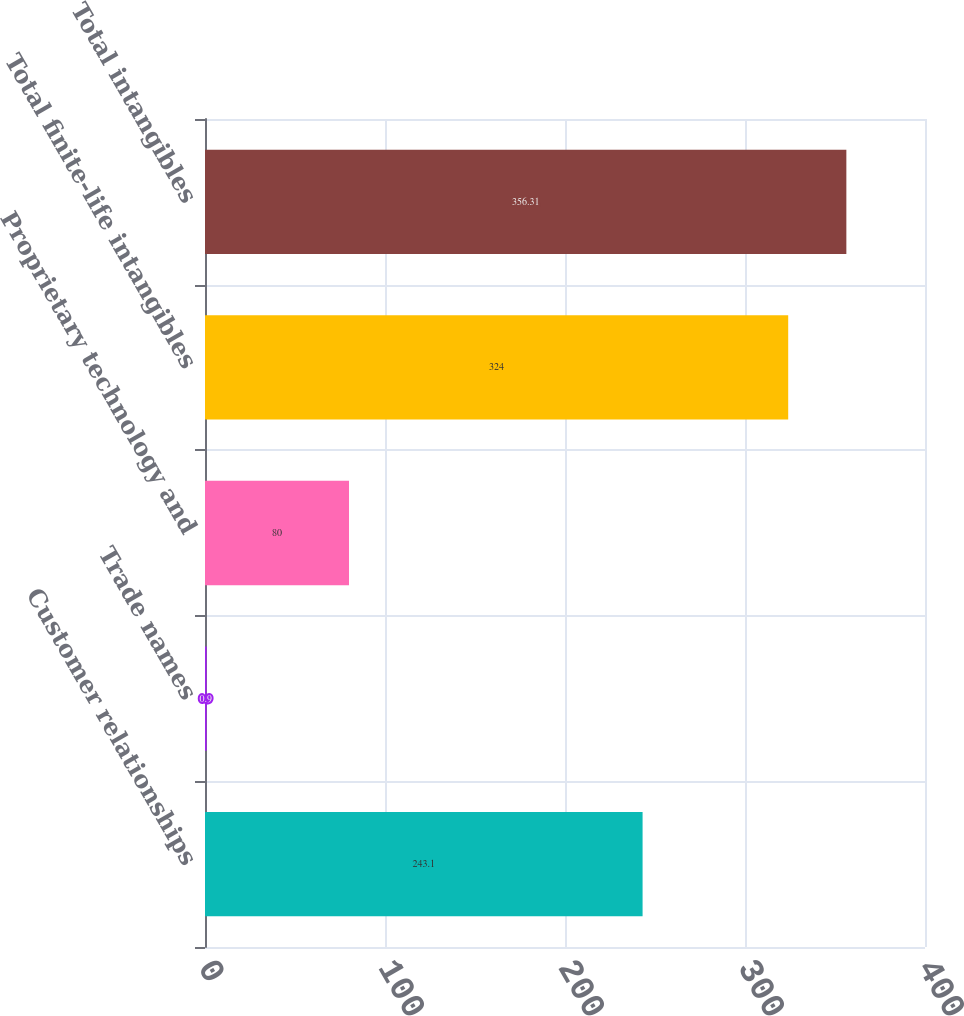Convert chart. <chart><loc_0><loc_0><loc_500><loc_500><bar_chart><fcel>Customer relationships<fcel>Trade names<fcel>Proprietary technology and<fcel>Total finite-life intangibles<fcel>Total intangibles<nl><fcel>243.1<fcel>0.9<fcel>80<fcel>324<fcel>356.31<nl></chart> 